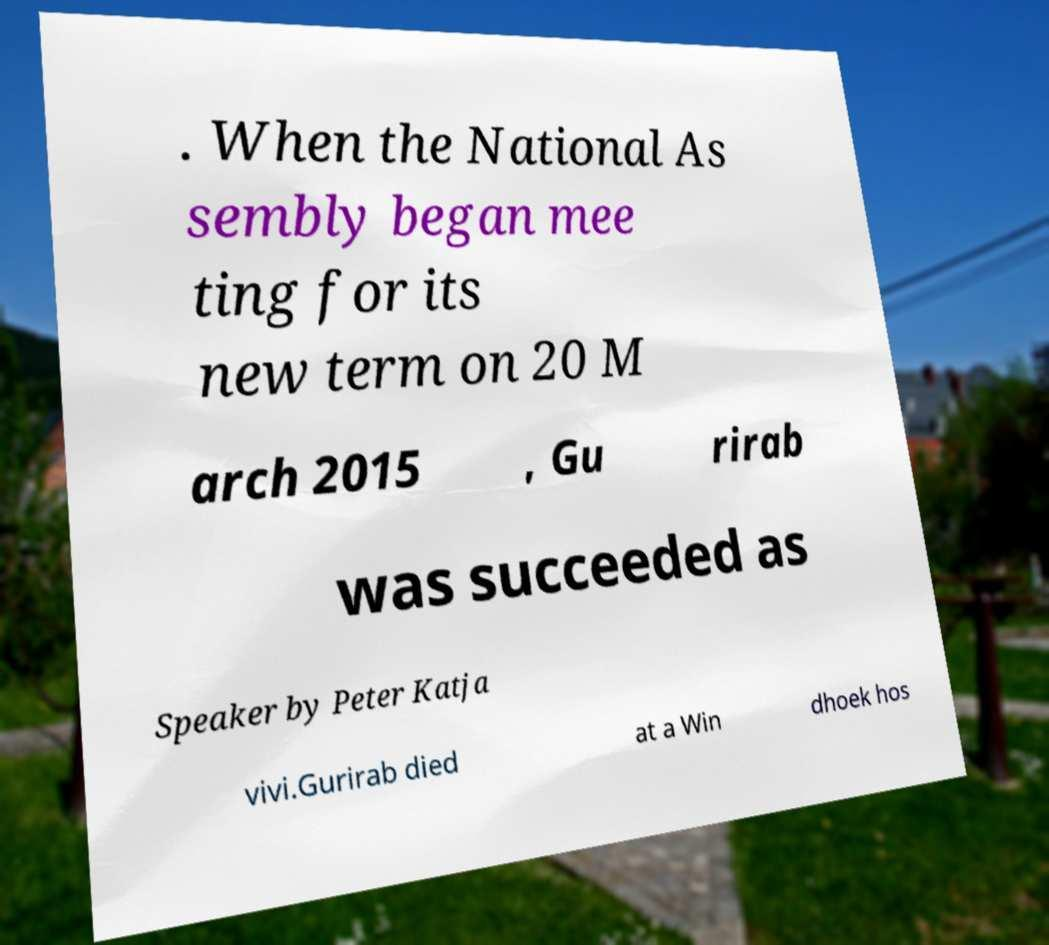Could you extract and type out the text from this image? . When the National As sembly began mee ting for its new term on 20 M arch 2015 , Gu rirab was succeeded as Speaker by Peter Katja vivi.Gurirab died at a Win dhoek hos 